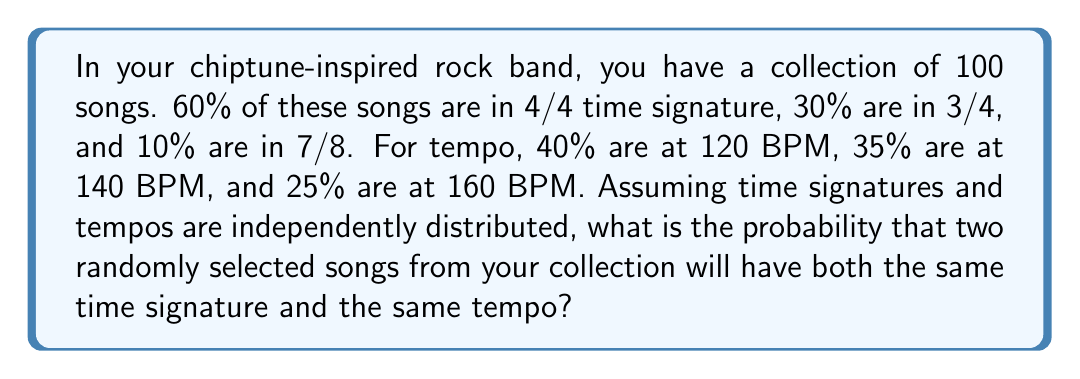Provide a solution to this math problem. Let's approach this step-by-step:

1) First, we need to calculate the probability of two randomly selected songs having the same time signature. This is given by:

   $P(\text{same time signature}) = 0.6^2 + 0.3^2 + 0.1^2 = 0.46$

2) Next, we calculate the probability of two randomly selected songs having the same tempo:

   $P(\text{same tempo}) = 0.4^2 + 0.35^2 + 0.25^2 = 0.3450$

3) Since time signatures and tempos are independently distributed, the probability of two songs having both the same time signature and the same tempo is the product of these two probabilities:

   $P(\text{same time signature and tempo}) = P(\text{same time signature}) \times P(\text{same tempo})$

4) Substituting the values:

   $P(\text{same time signature and tempo}) = 0.46 \times 0.3450 = 0.1587$

Therefore, the probability is approximately 0.1587 or 15.87%.
Answer: $0.1587$ 